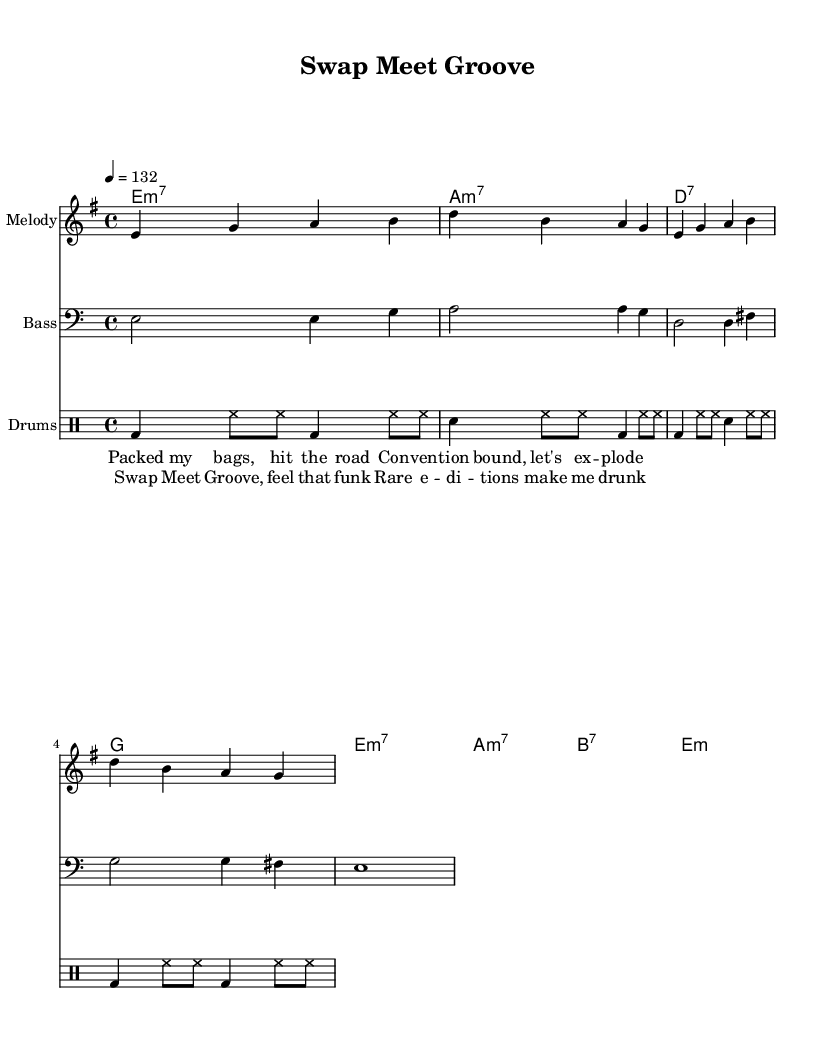What is the key signature of this music? The key signature is based on the beginning of the score, which indicates E minor, shown by one sharp on the staff.
Answer: E minor What is the time signature of this music? The time signature is specified in the global section of the code and indicates that each measure contains four beats.
Answer: 4/4 What is the tempo marking indicated in the sheet music? The tempo marking shows that the music is to be played at a speed of 132 beats per minute, as noted in the global section.
Answer: 132 How many measures are in the melody section? By counting the group of notes in the melody section, we find there are four measures provided in the melody part.
Answer: Four What type of chords are primarily used in this piece? The chords indicated in the chord names section suggest a prevalence of minor seventh and dominant seventh chords, fitting the funk genre.
Answer: Minor seventh and dominant seventh What is the lyrical theme addressed in the chorus? Analyzing the lyrics reveals the fun and excitement of attending a collector convention, as indicated by phrases about rare editions and groove.
Answer: Collector convention excitement What rhythmic feel is suggested by the drum part? The drum part displays a funk groove with a steady bass drum and hi-hat pattern, which is characteristic of high-energy funk music.
Answer: Funk groove 